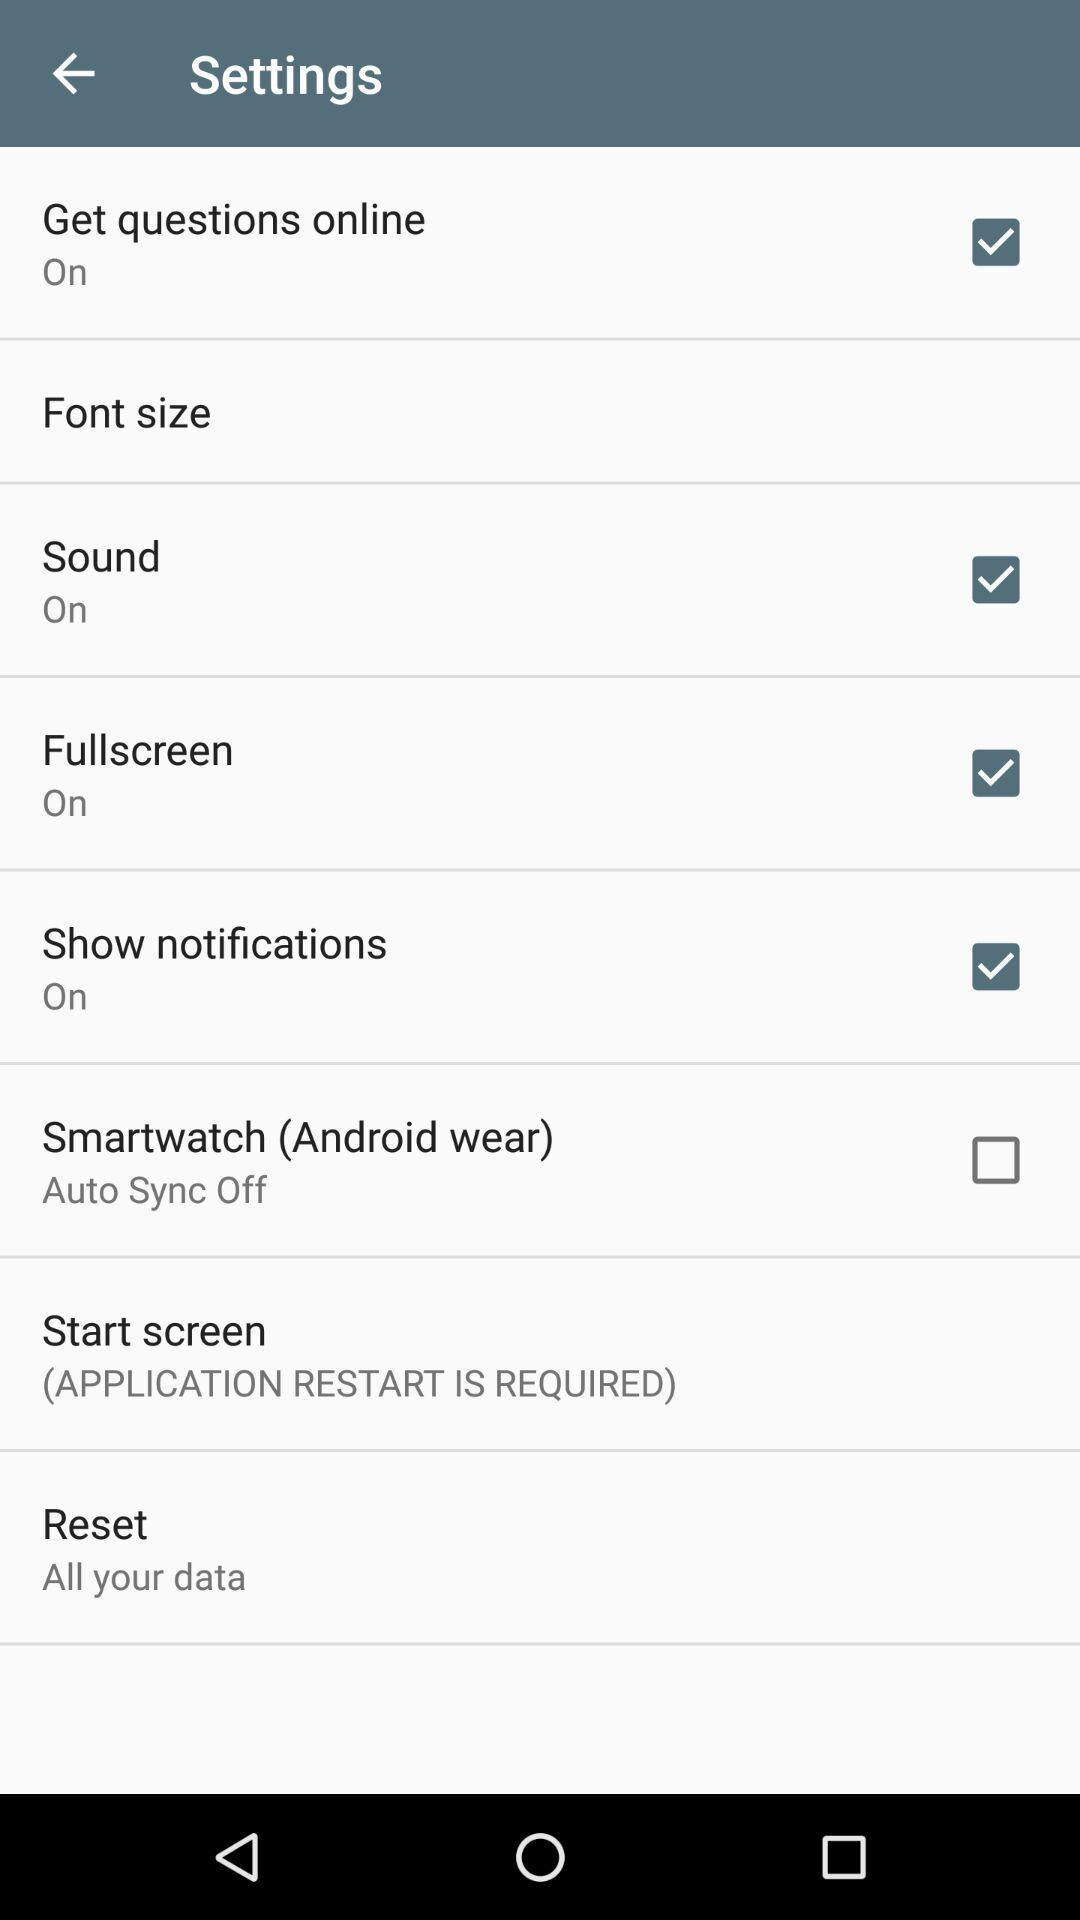What is the status of "Smartwatch"? The status of "Smartwatch" is "off". 